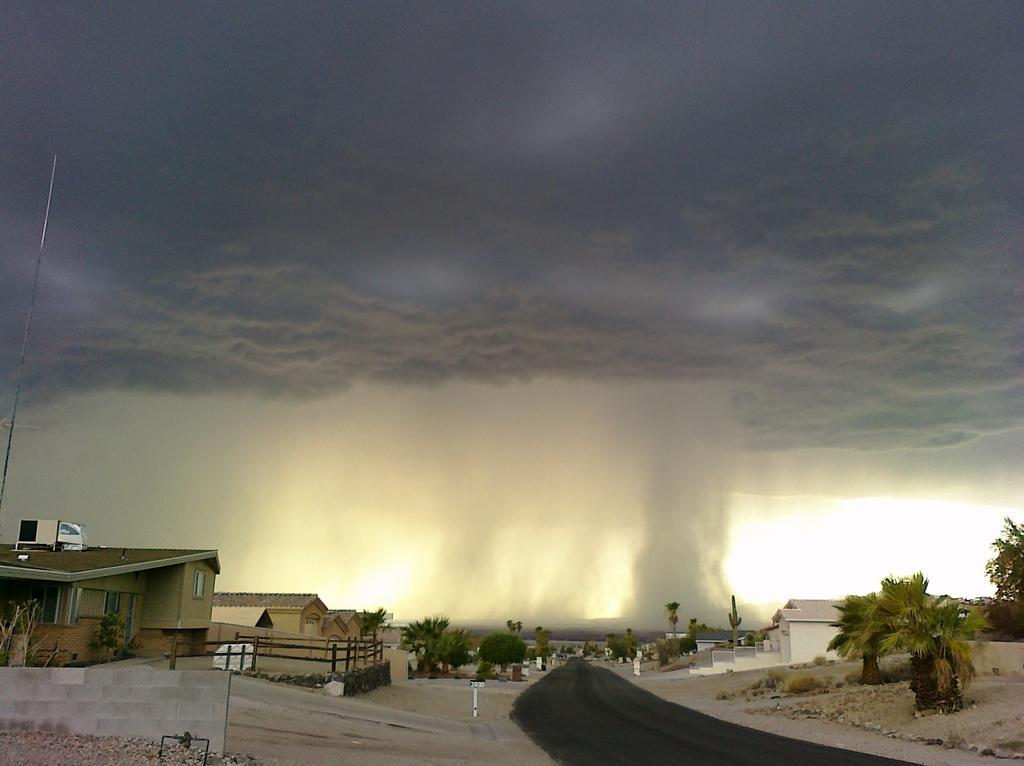Please provide a concise description of this image. In this image we can see there are trees, buildings, poles and road. And at the background it looks like raining and there is the sky. 